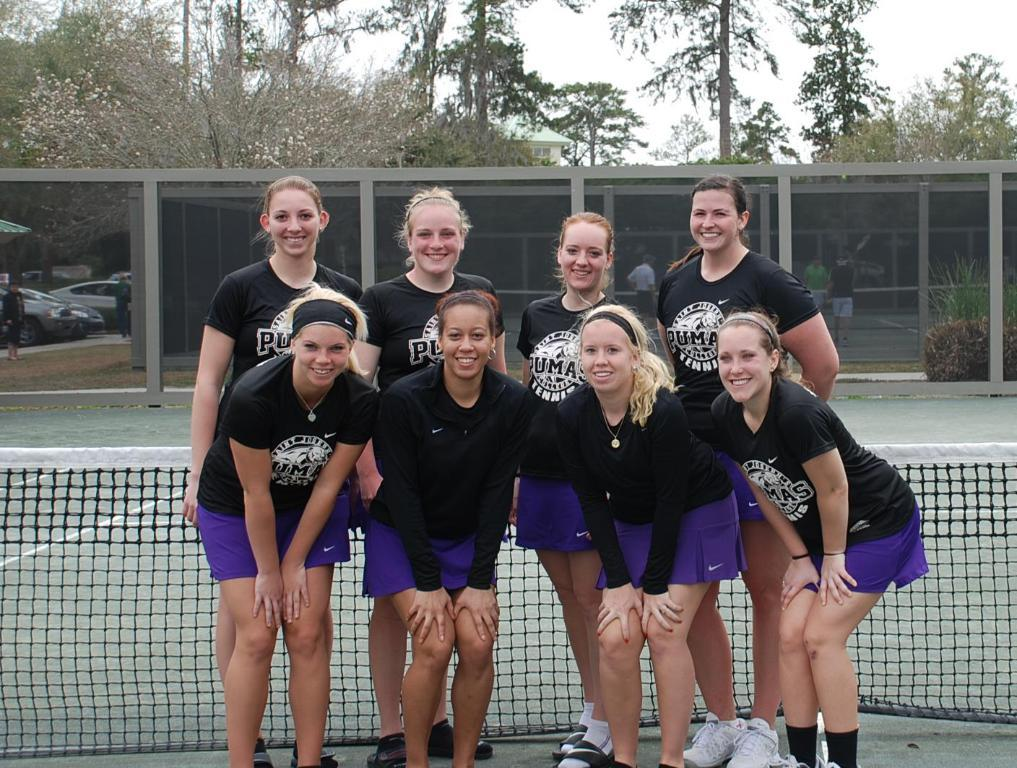<image>
Describe the image concisely. Several girls in Puma tops pose in front of a tennis net. 